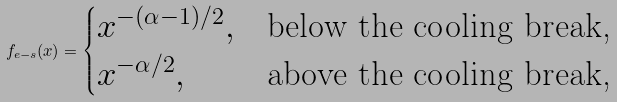<formula> <loc_0><loc_0><loc_500><loc_500>f _ { e - s } ( x ) = \begin{cases} x ^ { - ( \alpha - 1 ) / 2 } , & \text {below the cooling break,} \\ x ^ { - \alpha / 2 } , & \text {above the cooling break,} \end{cases}</formula> 